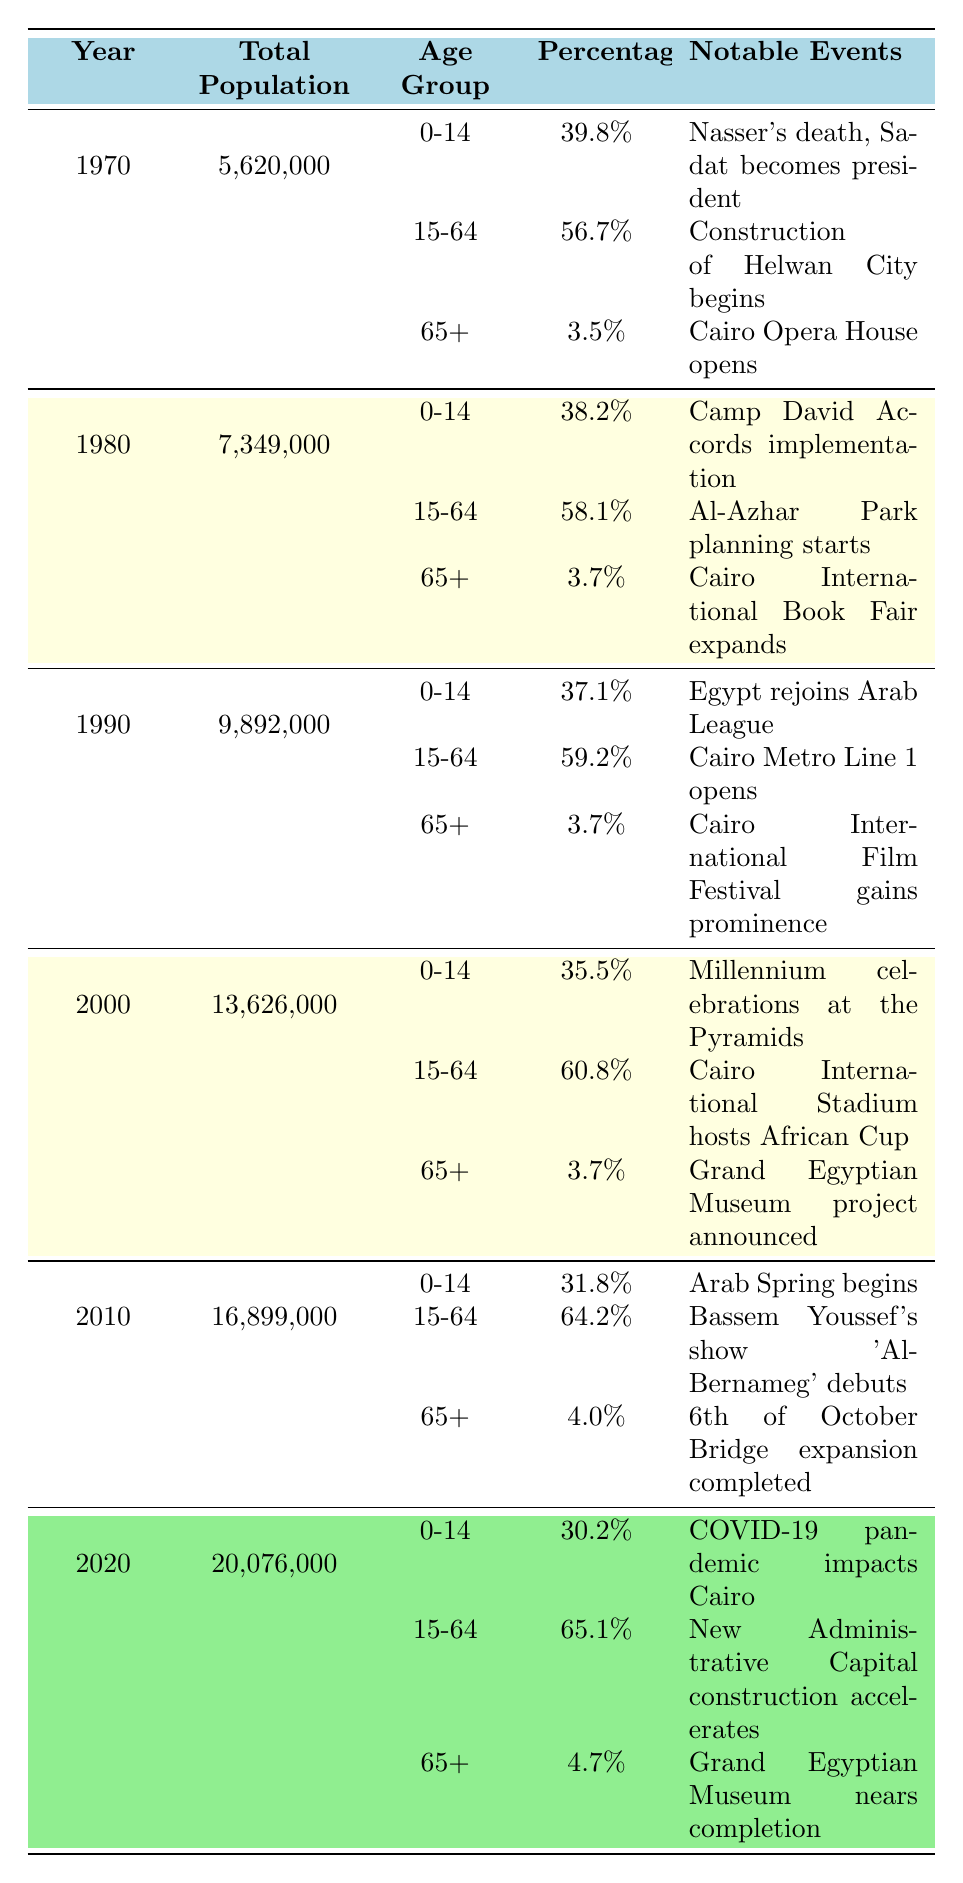What was the total population of Cairo in 2000? Referring to the table for the year 2000, the total population is listed as 13,626,000.
Answer: 13,626,000 What percentage of Cairo's population was aged 15-64 in 1990? Looking at the data for 1990, the percentage for the age group 15-64 is 59.2%.
Answer: 59.2% Which age group had the highest percentage of the population in 1980? In 1980, the age group 15-64 had the highest percentage at 58.1%, compared to 38.2% for the 0-14 age group and 3.7% for 65+.
Answer: 15-64 How did the percentage of the 0-14 age group change from 1970 to 2020? In 1970, the percentage of the 0-14 age group was 39.8%. In 2020, it decreased to 30.2%. The change is 39.8% - 30.2% = 9.6%.
Answer: Decreased by 9.6% Was the total population of Cairo more than 20 million in 2010? According to the table, the total population in 2010 was 16,899,000, which is less than 20 million.
Answer: No What was the percentage of the elderly population (65+) in 2010 compared to 1980? The percentage for 65+ in 2010 was 4.0% and in 1980 it was 3.7%. The difference is 4.0% - 3.7% = 0.3%.
Answer: Increased by 0.3% What was the notable event in Cairo during the year 2010? The table indicates that in 2010, Bassem Youssef's show 'Al-Bernameg' debuted as a notable event.
Answer: 'Al-Bernameg' debuted What was the trend of the percentage of the 15-64 age group from 1970 to 2020? The percentage for 15-64 started at 56.7% in 1970, increased to 65.1% in 2020. The trend shows a steady increase in this age group's percentage over the decades.
Answer: Steady increase Calculate the average percentage of the 65+ age group from 1970 to 2020. The percentages for 65+ are 3.5% (1970), 3.7% (1980), 3.7% (1990), 3.7% (2000), 4.0% (2010), and 4.7% (2020). The average is (3.5 + 3.7 + 3.7 + 3.7 + 4.0 + 4.7) / 6 = 3.83%.
Answer: 3.83% What was the percentage of the population aged 0-14 in 2000 compared to 2010? The percentage for 0-14 in 2000 was 35.5%, and in 2010 it was 31.8%. This shows a decrease of 35.5% - 31.8% = 3.7%.
Answer: Decreased by 3.7% In which decade did the total population of Cairo first exceed 10 million? The total population first exceeded 10 million in the year 1990 when it reached 9,892,000, which is just below 10 million, but the following year it surpasses this mark.
Answer: 1990 